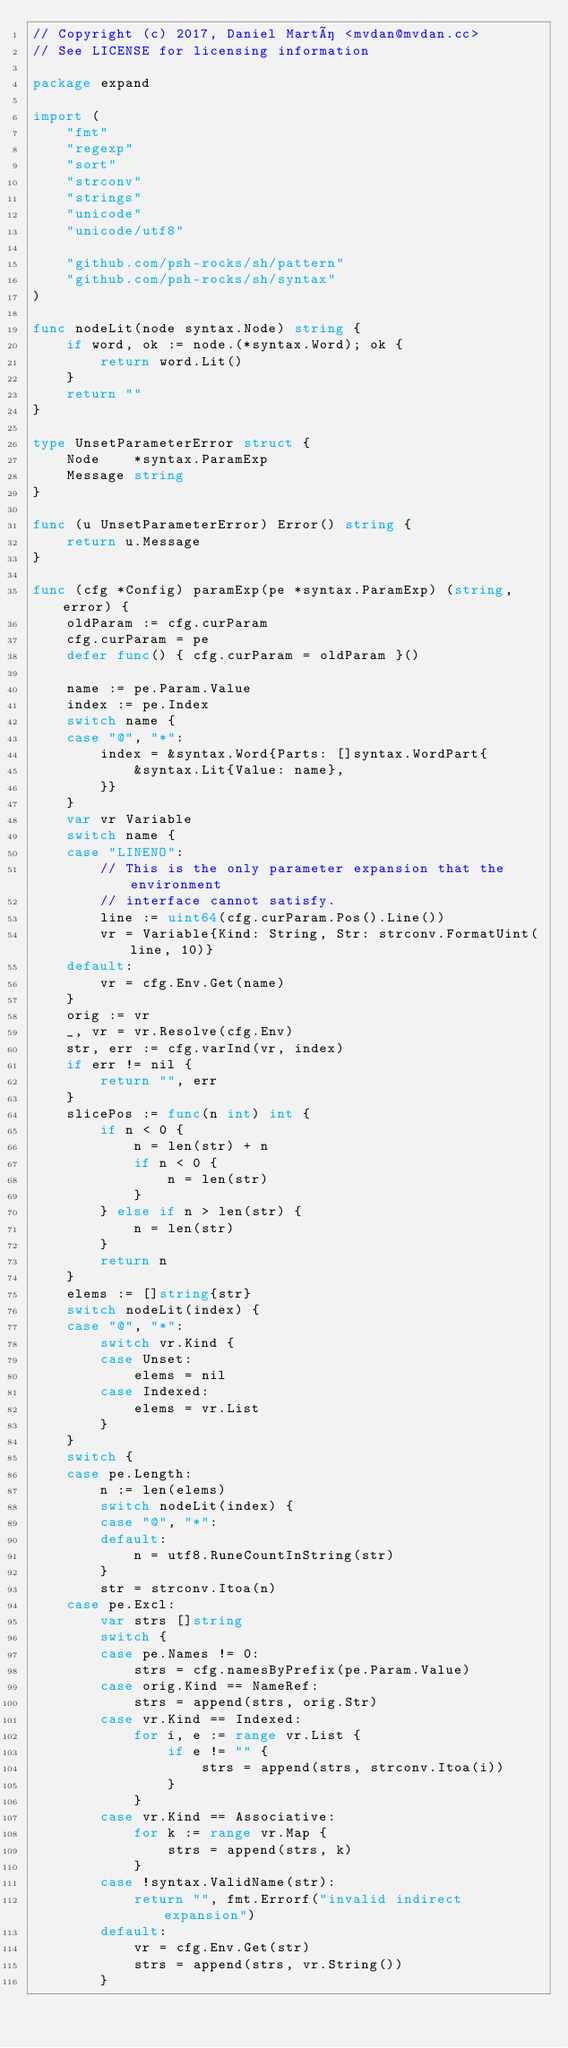<code> <loc_0><loc_0><loc_500><loc_500><_Go_>// Copyright (c) 2017, Daniel Martí <mvdan@mvdan.cc>
// See LICENSE for licensing information

package expand

import (
	"fmt"
	"regexp"
	"sort"
	"strconv"
	"strings"
	"unicode"
	"unicode/utf8"

	"github.com/psh-rocks/sh/pattern"
	"github.com/psh-rocks/sh/syntax"
)

func nodeLit(node syntax.Node) string {
	if word, ok := node.(*syntax.Word); ok {
		return word.Lit()
	}
	return ""
}

type UnsetParameterError struct {
	Node    *syntax.ParamExp
	Message string
}

func (u UnsetParameterError) Error() string {
	return u.Message
}

func (cfg *Config) paramExp(pe *syntax.ParamExp) (string, error) {
	oldParam := cfg.curParam
	cfg.curParam = pe
	defer func() { cfg.curParam = oldParam }()

	name := pe.Param.Value
	index := pe.Index
	switch name {
	case "@", "*":
		index = &syntax.Word{Parts: []syntax.WordPart{
			&syntax.Lit{Value: name},
		}}
	}
	var vr Variable
	switch name {
	case "LINENO":
		// This is the only parameter expansion that the environment
		// interface cannot satisfy.
		line := uint64(cfg.curParam.Pos().Line())
		vr = Variable{Kind: String, Str: strconv.FormatUint(line, 10)}
	default:
		vr = cfg.Env.Get(name)
	}
	orig := vr
	_, vr = vr.Resolve(cfg.Env)
	str, err := cfg.varInd(vr, index)
	if err != nil {
		return "", err
	}
	slicePos := func(n int) int {
		if n < 0 {
			n = len(str) + n
			if n < 0 {
				n = len(str)
			}
		} else if n > len(str) {
			n = len(str)
		}
		return n
	}
	elems := []string{str}
	switch nodeLit(index) {
	case "@", "*":
		switch vr.Kind {
		case Unset:
			elems = nil
		case Indexed:
			elems = vr.List
		}
	}
	switch {
	case pe.Length:
		n := len(elems)
		switch nodeLit(index) {
		case "@", "*":
		default:
			n = utf8.RuneCountInString(str)
		}
		str = strconv.Itoa(n)
	case pe.Excl:
		var strs []string
		switch {
		case pe.Names != 0:
			strs = cfg.namesByPrefix(pe.Param.Value)
		case orig.Kind == NameRef:
			strs = append(strs, orig.Str)
		case vr.Kind == Indexed:
			for i, e := range vr.List {
				if e != "" {
					strs = append(strs, strconv.Itoa(i))
				}
			}
		case vr.Kind == Associative:
			for k := range vr.Map {
				strs = append(strs, k)
			}
		case !syntax.ValidName(str):
			return "", fmt.Errorf("invalid indirect expansion")
		default:
			vr = cfg.Env.Get(str)
			strs = append(strs, vr.String())
		}</code> 